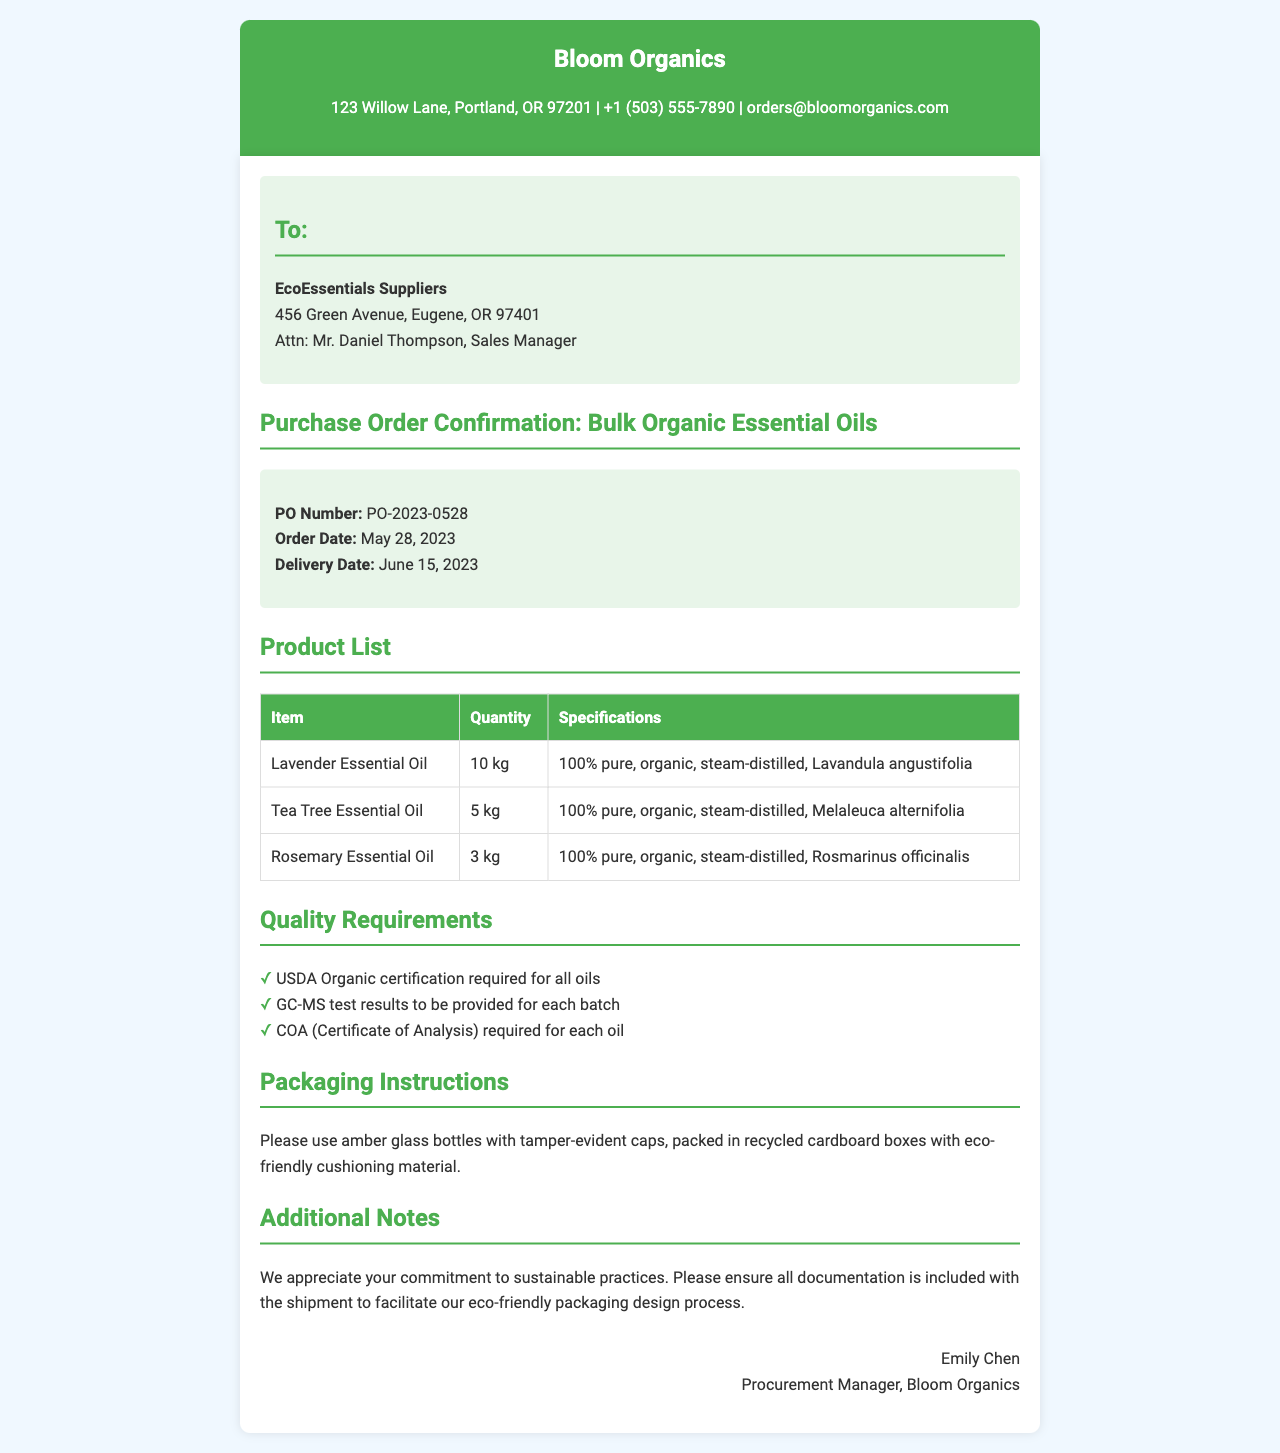What is the PO Number? The PO Number is listed in the order details section of the document as PO-2023-0528.
Answer: PO-2023-0528 What is the delivery date? The delivery date can be found in the order details section, which states it is June 15, 2023.
Answer: June 15, 2023 How many kg of Tea Tree Essential Oil are ordered? The quantity of Tea Tree Essential Oil is noted in the product list table as 5 kg.
Answer: 5 kg What type of packaging is required? The packaging instructions specify amber glass bottles with tamper-evident caps and recycled cardboard boxes.
Answer: Amber glass bottles What certification is required for all oils? The quality requirements specify that USDA Organic certification is mandatory for all oils.
Answer: USDA Organic Who is the recipient of the order? The recipient's name is mentioned at the beginning, and it is EcoEssentials Suppliers.
Answer: EcoEssentials Suppliers What is the total quantity of Lavender Essential Oil ordered? The total quantity of Lavender Essential Oil is 10 kg as per the product list.
Answer: 10 kg What is the name of the Procurement Manager? The signature section identifies the Procurement Manager as Emily Chen.
Answer: Emily Chen What is the main focus of the additional notes? The additional notes express appreciation for sustainable practices and highlight the need for documentation with the shipment.
Answer: Sustainable practices 